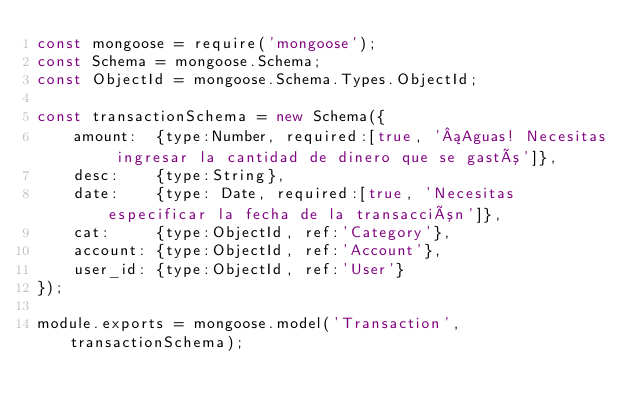<code> <loc_0><loc_0><loc_500><loc_500><_JavaScript_>const mongoose = require('mongoose');
const Schema = mongoose.Schema;
const ObjectId = mongoose.Schema.Types.ObjectId;

const transactionSchema = new Schema({
    amount:  {type:Number, required:[true, '¡Aguas! Necesitas ingresar la cantidad de dinero que se gastó']},
    desc:    {type:String},
    date:    {type: Date, required:[true, 'Necesitas especificar la fecha de la transacción']},
    cat:     {type:ObjectId, ref:'Category'},
    account: {type:ObjectId, ref:'Account'},
    user_id: {type:ObjectId, ref:'User'}
});

module.exports = mongoose.model('Transaction', transactionSchema);</code> 